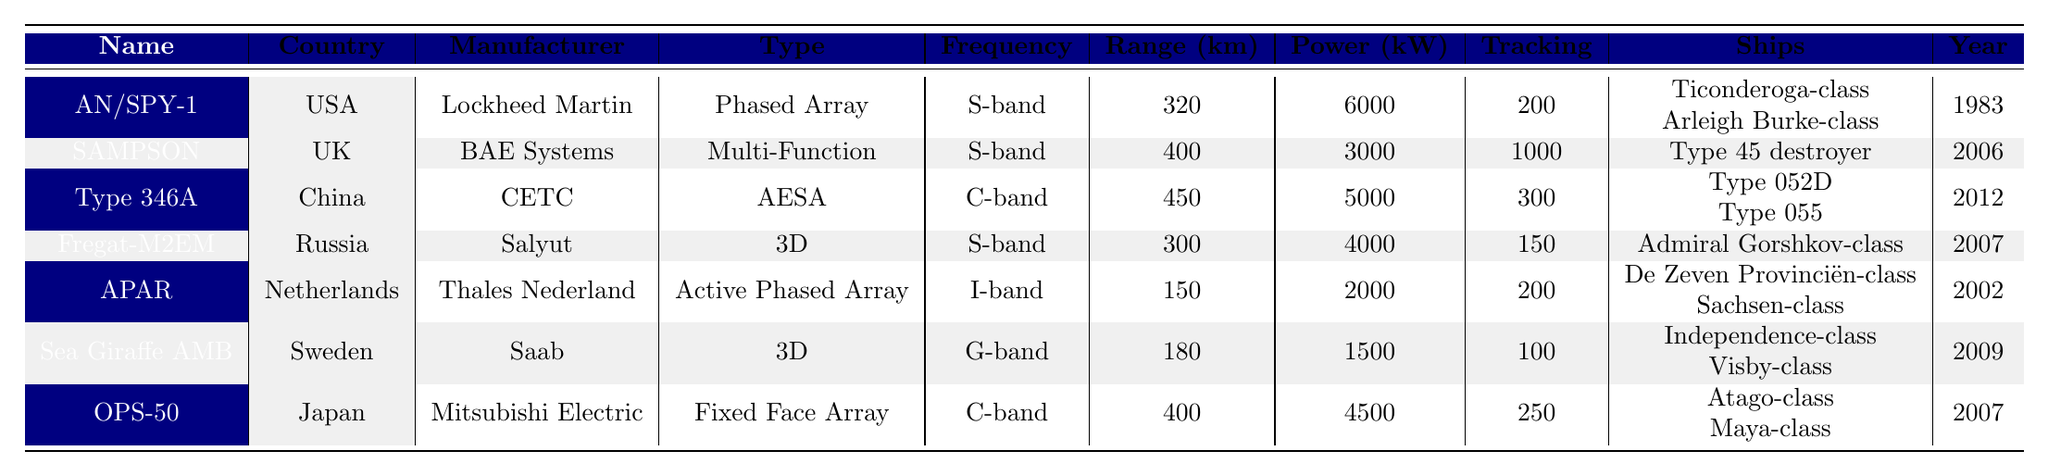What is the range of the AN/SPY-1 radar system? The table shows that the range of the AN/SPY-1 radar system is listed as 320 km.
Answer: 320 km Which radar system has the highest tracking capacity? By analyzing the tracking capacities in the table, SAMPSON has a tracking capacity of 1000, which is the highest among all listed systems.
Answer: SAMPSON What type of radar is used by the Type 45 destroyer? The table indicates that the Type 45 destroyer is equipped with the SAMPSON radar system, which is a Multi-Function type.
Answer: Multi-Function Is the frequency band of the Fregat-M2EM radar system S-band? Yes, the table shows that the frequency band for the Fregat-M2EM radar system is indeed S-band.
Answer: Yes List all radar systems introduced before 2000. Reviewing the introduction years in the table, the systems that were introduced before 2000 are: AN/SPY-1 (1983), APAR (2002), and the various systems under development around that time. However, APAR was introduced in 2002, so only AN/SPY-1 is valid.
Answer: AN/SPY-1 What is the average range of all radar systems listed in the table? The ranges of the radar systems are 320, 400, 450, 300, 150, 180, and 400 km. Summing these values gives 2200 km, and dividing by 7 yields an average range of approximately 314.29 km.
Answer: 314.29 km Which country has radar systems operating in the C-band frequency? The radar systems in the table that operate in the C-band frequency band are Type 346A and OPS-50, with corresponding countries China and Japan.
Answer: China and Japan Which radar system has the lowest power output? Looking at the power output values in the table, the Sea Giraffe AMB radar system has the lowest power output of 1500 kW.
Answer: Sea Giraffe AMB How many different types of radar systems are represented in the table? The table lists six different types of radar systems: Phased Array, Multi-Function, Active Electronically Scanned Array, 3D, Active Phased Array, and Fixed Face Array. Counting these distinct categories gives us six types.
Answer: 6 types Which naval force uses the Type 052D destroyer and what radar system does it use? The table shows the Type 052D destroyer is used by China and equipped with the Type 346A radar system.
Answer: China, Type 346A What is the difference in range between the radar systems with the highest and lowest range? The highest range is 450 km (Type 346A), and the lowest is 150 km (APAR). The difference in range is 450 - 150 = 300 km.
Answer: 300 km 